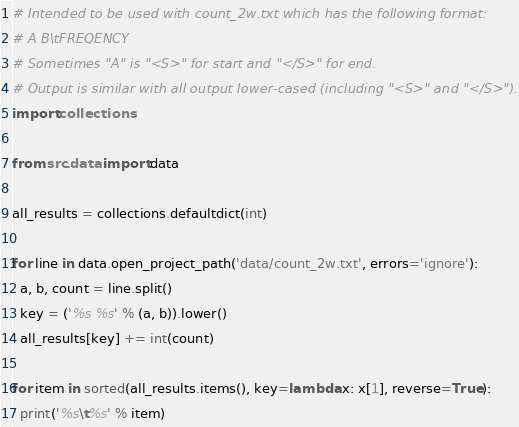Convert code to text. <code><loc_0><loc_0><loc_500><loc_500><_Python_># Intended to be used with count_2w.txt which has the following format:
# A B\tFREQENCY
# Sometimes "A" is "<S>" for start and "</S>" for end.
# Output is similar with all output lower-cased (including "<S>" and "</S>").
import collections

from src.data import data

all_results = collections.defaultdict(int)

for line in data.open_project_path('data/count_2w.txt', errors='ignore'):
  a, b, count = line.split()
  key = ('%s %s' % (a, b)).lower()
  all_results[key] += int(count)

for item in sorted(all_results.items(), key=lambda x: x[1], reverse=True):
  print('%s\t%s' % item)
</code> 